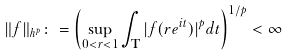<formula> <loc_0><loc_0><loc_500><loc_500>\| f \| _ { h ^ { p } } \colon = \left ( \sup _ { 0 < r < 1 } \int _ { \mathbf T } | f ( r e ^ { i t } ) | ^ { p } d t \right ) ^ { 1 / p } < \infty</formula> 